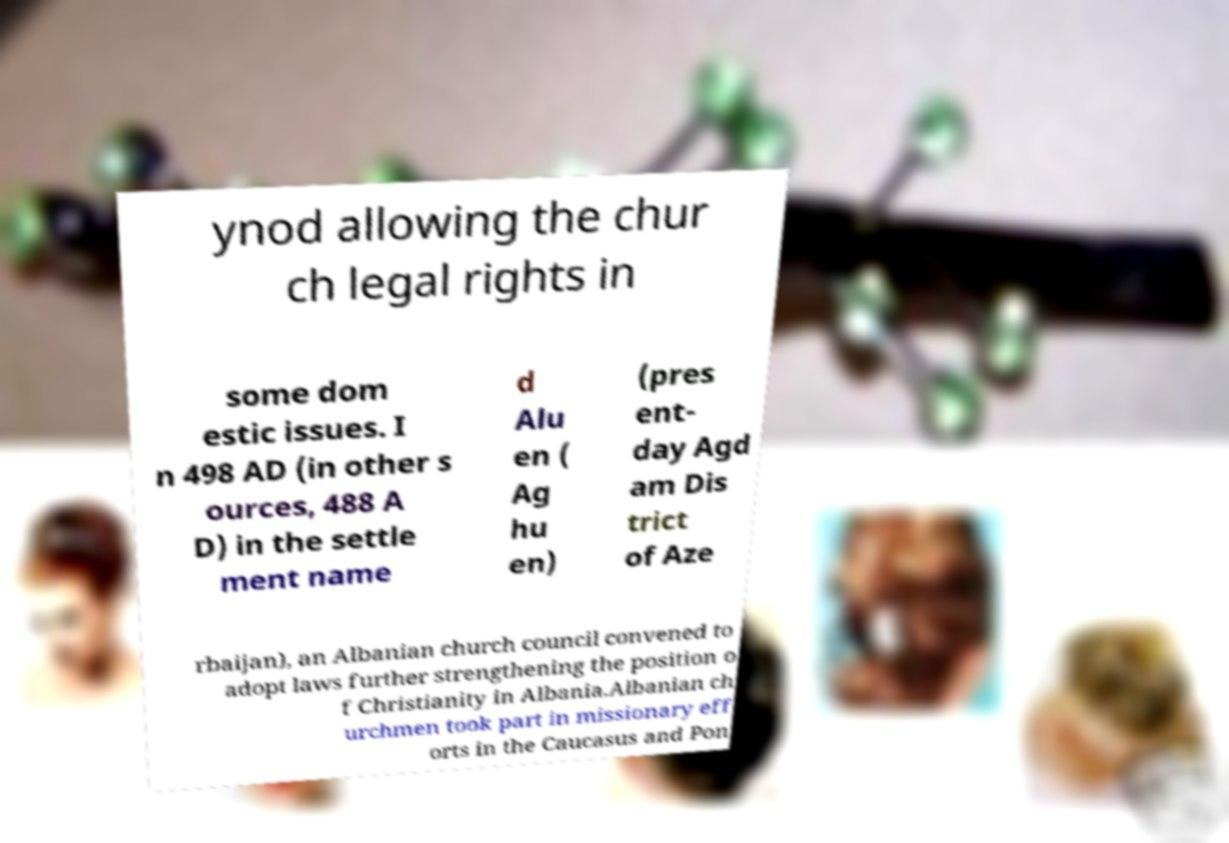Please read and relay the text visible in this image. What does it say? ynod allowing the chur ch legal rights in some dom estic issues. I n 498 AD (in other s ources, 488 A D) in the settle ment name d Alu en ( Ag hu en) (pres ent- day Agd am Dis trict of Aze rbaijan), an Albanian church council convened to adopt laws further strengthening the position o f Christianity in Albania.Albanian ch urchmen took part in missionary eff orts in the Caucasus and Pon 